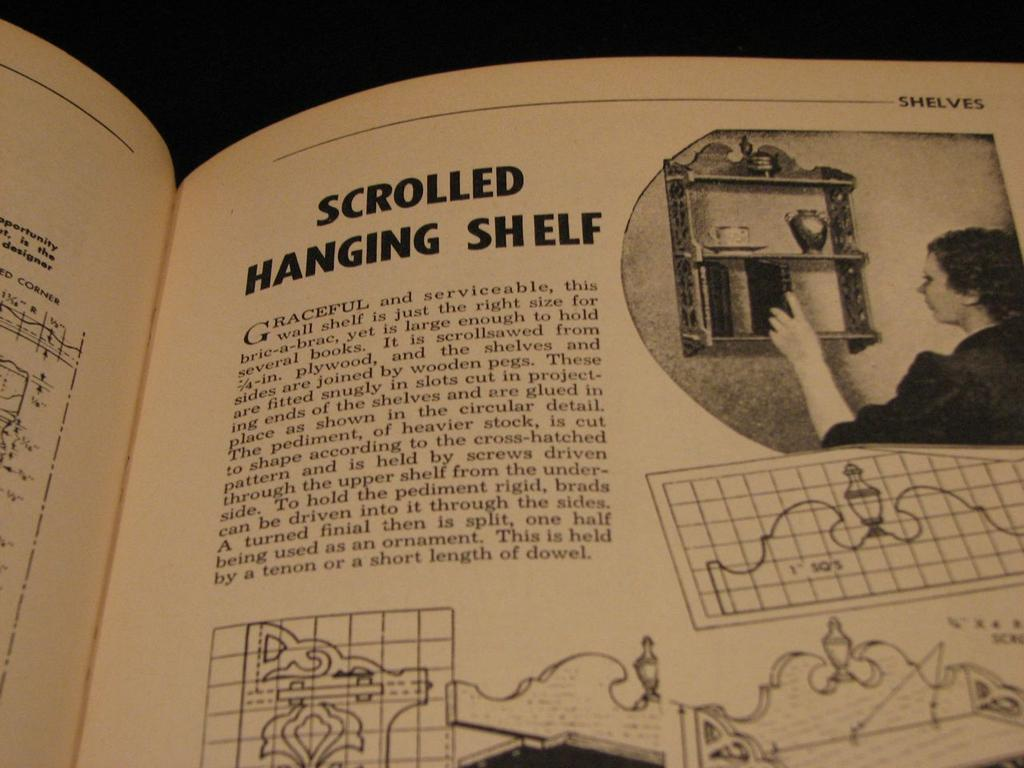<image>
Give a short and clear explanation of the subsequent image. A book is open and the heading shelves is in the upper right corner. 